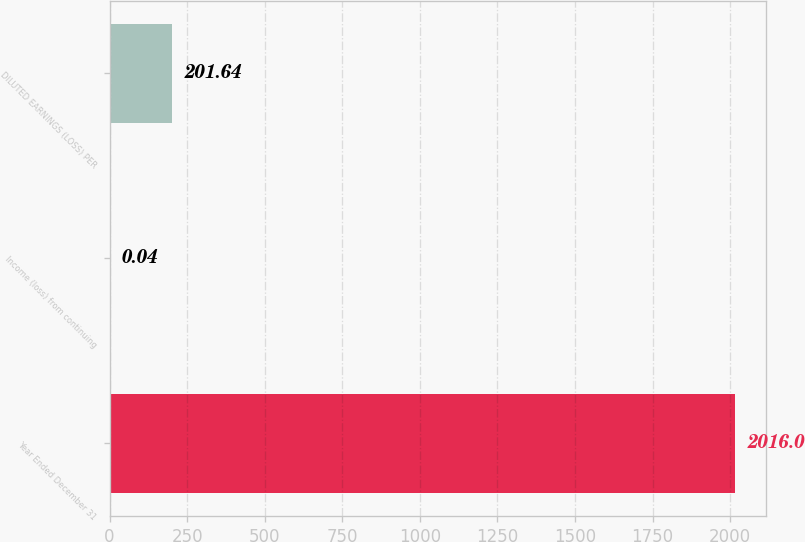Convert chart. <chart><loc_0><loc_0><loc_500><loc_500><bar_chart><fcel>Year Ended December 31<fcel>Income (loss) from continuing<fcel>DILUTED EARNINGS (LOSS) PER<nl><fcel>2016<fcel>0.04<fcel>201.64<nl></chart> 